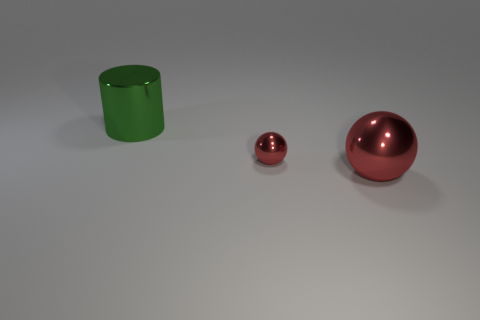Subtract 1 spheres. How many spheres are left? 1 Add 2 red cylinders. How many objects exist? 5 Subtract all balls. How many objects are left? 1 Subtract all purple cubes. How many purple balls are left? 0 Add 1 large green cylinders. How many large green cylinders are left? 2 Add 1 large balls. How many large balls exist? 2 Subtract 1 red spheres. How many objects are left? 2 Subtract all gray balls. Subtract all purple blocks. How many balls are left? 2 Subtract all tiny red shiny balls. Subtract all large cylinders. How many objects are left? 1 